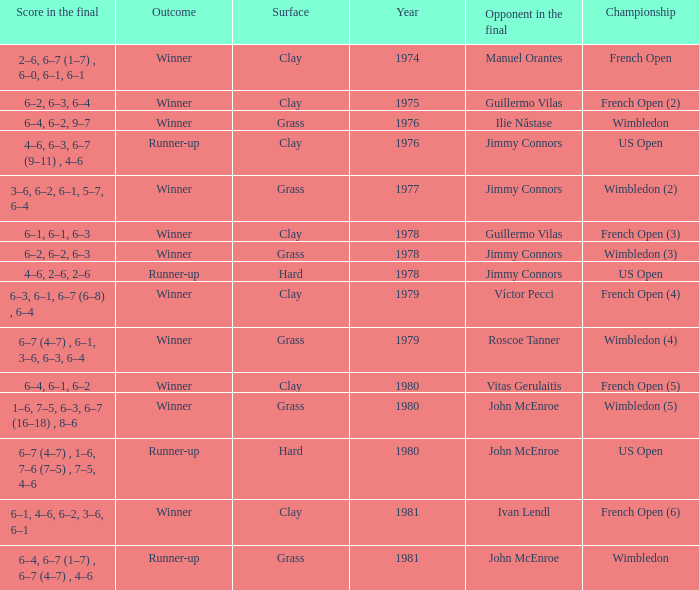What is every score in the final for opponent in final John Mcenroe at US Open? 6–7 (4–7) , 1–6, 7–6 (7–5) , 7–5, 4–6. 